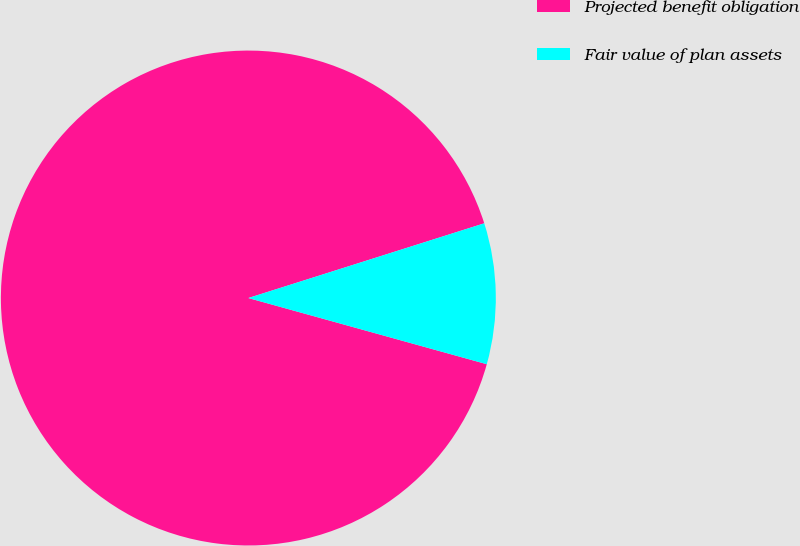Convert chart. <chart><loc_0><loc_0><loc_500><loc_500><pie_chart><fcel>Projected benefit obligation<fcel>Fair value of plan assets<nl><fcel>90.81%<fcel>9.19%<nl></chart> 